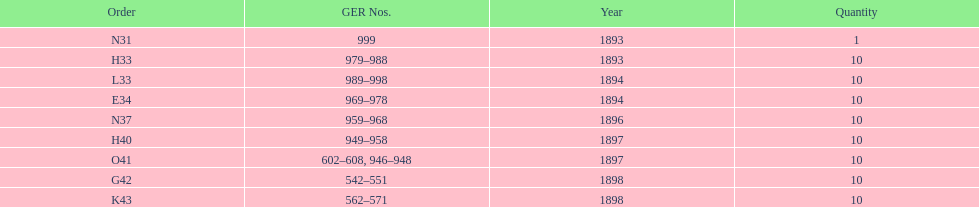Which year between 1893 and 1898 was there not an order? 1895. 